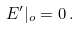<formula> <loc_0><loc_0><loc_500><loc_500>E ^ { \prime } | _ { o } = 0 \, .</formula> 